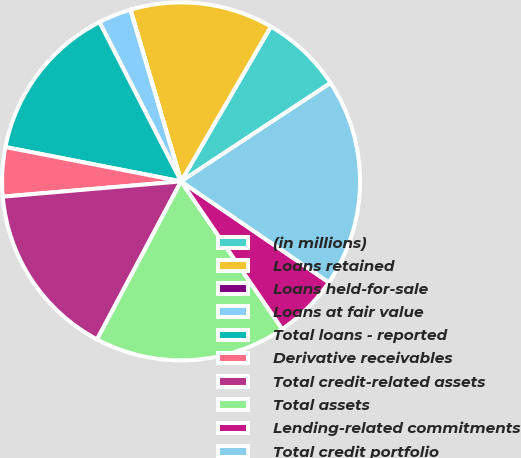Convert chart to OTSL. <chart><loc_0><loc_0><loc_500><loc_500><pie_chart><fcel>(in millions)<fcel>Loans retained<fcel>Loans held-for-sale<fcel>Loans at fair value<fcel>Total loans - reported<fcel>Derivative receivables<fcel>Total credit-related assets<fcel>Total assets<fcel>Lending-related commitments<fcel>Total credit portfolio<nl><fcel>7.37%<fcel>12.92%<fcel>0.02%<fcel>2.96%<fcel>14.39%<fcel>4.43%<fcel>15.86%<fcel>17.33%<fcel>5.9%<fcel>18.8%<nl></chart> 